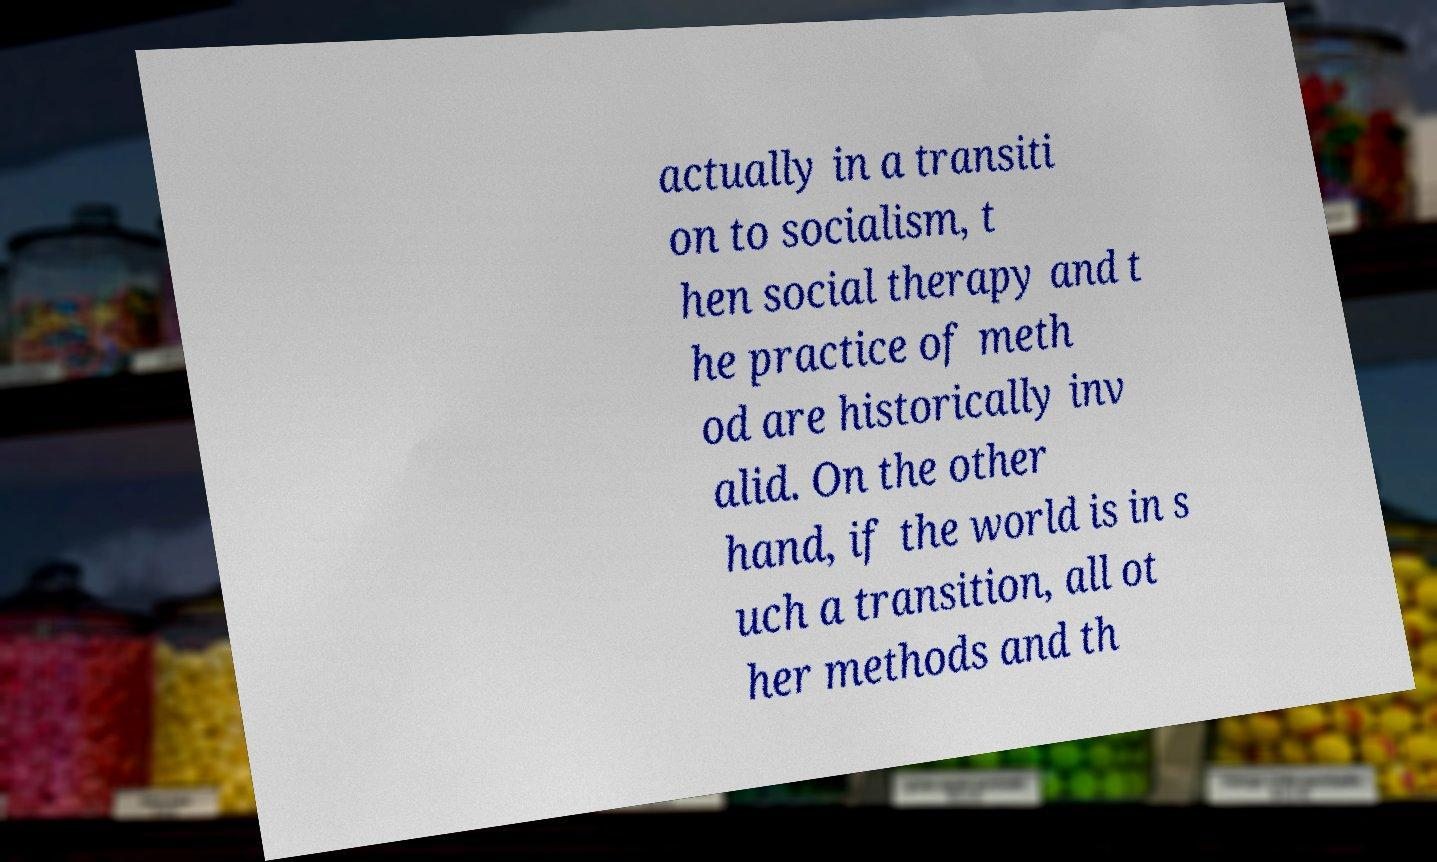I need the written content from this picture converted into text. Can you do that? actually in a transiti on to socialism, t hen social therapy and t he practice of meth od are historically inv alid. On the other hand, if the world is in s uch a transition, all ot her methods and th 